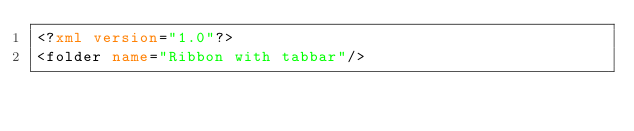<code> <loc_0><loc_0><loc_500><loc_500><_XML_><?xml version="1.0"?>
<folder name="Ribbon with tabbar"/></code> 